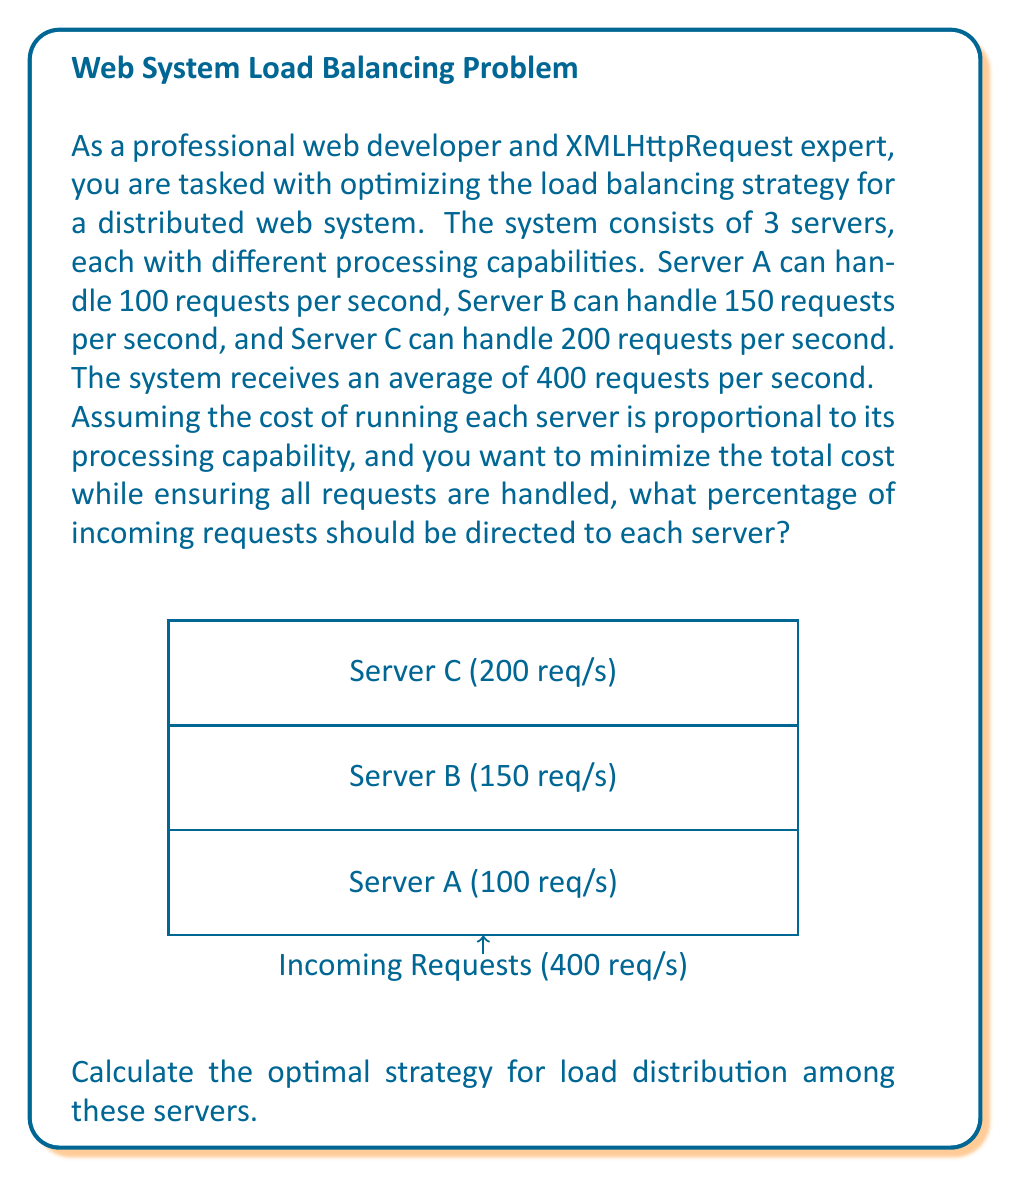Teach me how to tackle this problem. Let's approach this step-by-step using game theory concepts:

1) First, we need to define our variables:
   Let $x_A$, $x_B$, and $x_C$ be the fractions of requests directed to Servers A, B, and C respectively.

2) We can set up our constraints:
   $$x_A + x_B + x_C = 1$$ (all requests must be handled)
   $$100x_A + 150x_B + 200x_C = 400$$ (total requests handled must equal incoming requests)

3) Our objective is to minimize cost while satisfying these constraints. The cost is proportional to the server's capability, so we want to use the less capable servers as much as possible.

4) We can solve this system of equations:
   From the first equation: $x_C = 1 - x_A - x_B$
   Substituting into the second equation:
   $$100x_A + 150x_B + 200(1 - x_A - x_B) = 400$$
   $$100x_A + 150x_B + 200 - 200x_A - 200x_B = 400$$
   $$-100x_A - 50x_B = 200$$
   $$2x_A + x_B = -4$$

5) To minimize cost, we should use Server A to its full capacity:
   $100x_A = 100$, so $x_A = 1$

6) Substituting this into the equation from step 4:
   $$2(1) + x_B = -4$$
   $$x_B = -6$$

   This is impossible as $x_B$ cannot be negative.

7) Therefore, we use Server A to its full capacity, and distribute the remaining requests between B and C:
   $x_A = 100/400 = 0.25$
   Remaining requests: $400 - 100 = 300$

8) For the remaining 300 requests, we use Server B to its full capacity:
   $x_B = 150/400 = 0.375$

9) The rest goes to Server C:
   $x_C = 1 - x_A - x_B = 1 - 0.25 - 0.375 = 0.375$

10) Verifying:
    $100(0.25) + 150(0.375) + 200(0.375) = 25 + 56.25 + 75 = 156.25$
    $156.25 * 400/100 = 625$ requests per second, which is our total server capacity.

Therefore, the optimal strategy is to send 25% of requests to Server A, 37.5% to Server B, and 37.5% to Server C.
Answer: Server A: 25%, Server B: 37.5%, Server C: 37.5% 